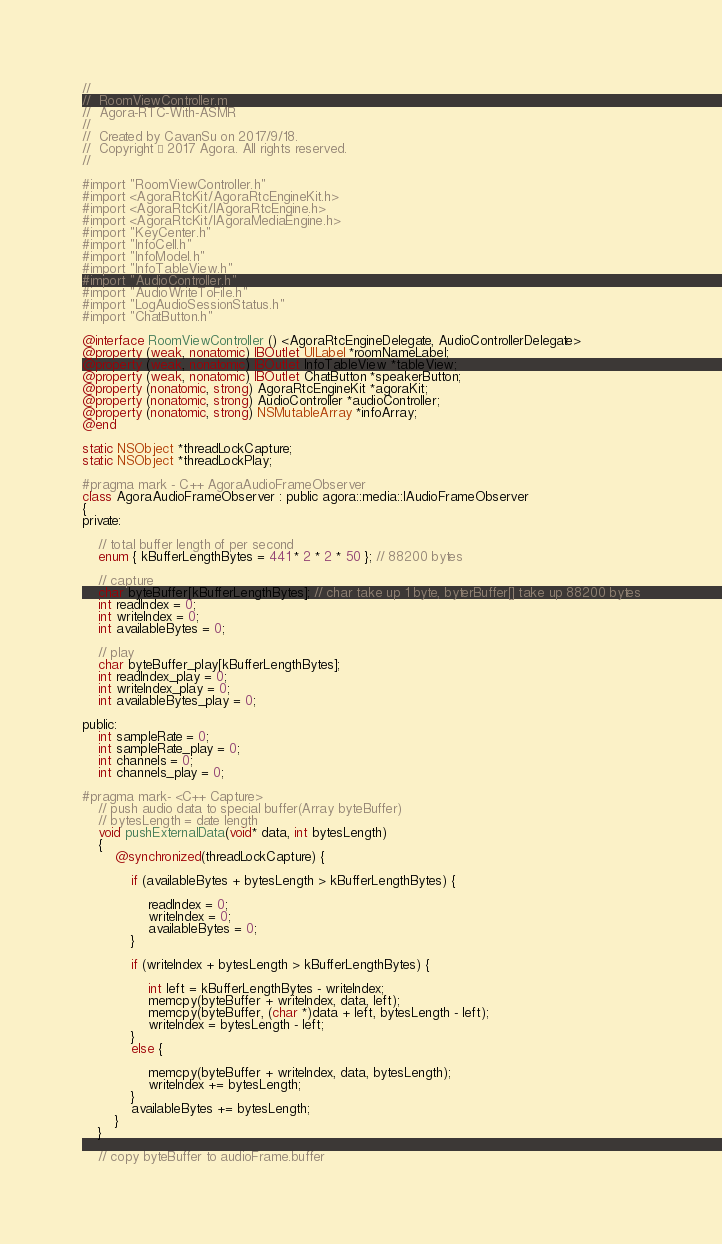<code> <loc_0><loc_0><loc_500><loc_500><_ObjectiveC_>//
//  RoomViewController.m
//  Agora-RTC-With-ASMR
//
//  Created by CavanSu on 2017/9/18.
//  Copyright © 2017 Agora. All rights reserved.
//

#import "RoomViewController.h"
#import <AgoraRtcKit/AgoraRtcEngineKit.h>
#import <AgoraRtcKit/IAgoraRtcEngine.h>
#import <AgoraRtcKit/IAgoraMediaEngine.h>
#import "KeyCenter.h"
#import "InfoCell.h"
#import "InfoModel.h"
#import "InfoTableView.h"
#import "AudioController.h"
#import "AudioWriteToFile.h"
#import "LogAudioSessionStatus.h"
#import "ChatButton.h"

@interface RoomViewController () <AgoraRtcEngineDelegate, AudioControllerDelegate>
@property (weak, nonatomic) IBOutlet UILabel *roomNameLabel;
@property (weak, nonatomic) IBOutlet InfoTableView *tableView;
@property (weak, nonatomic) IBOutlet ChatButton *speakerButton;
@property (nonatomic, strong) AgoraRtcEngineKit *agoraKit;
@property (nonatomic, strong) AudioController *audioController;
@property (nonatomic, strong) NSMutableArray *infoArray;
@end

static NSObject *threadLockCapture;
static NSObject *threadLockPlay;

#pragma mark - C++ AgoraAudioFrameObserver
class AgoraAudioFrameObserver : public agora::media::IAudioFrameObserver
{
private:
    
    // total buffer length of per second
    enum { kBufferLengthBytes = 441 * 2 * 2 * 50 }; // 88200 bytes
    
    // capture
    char byteBuffer[kBufferLengthBytes]; // char take up 1 byte, byterBuffer[] take up 88200 bytes
    int readIndex = 0;
    int writeIndex = 0;
    int availableBytes = 0;
    
    // play
    char byteBuffer_play[kBufferLengthBytes];
    int readIndex_play = 0;
    int writeIndex_play = 0;
    int availableBytes_play = 0;
    
public:
    int sampleRate = 0;
    int sampleRate_play = 0;
    int channels = 0;
    int channels_play = 0;
    
#pragma mark- <C++ Capture>
    // push audio data to special buffer(Array byteBuffer)
    // bytesLength = date length
    void pushExternalData(void* data, int bytesLength)
    {
        @synchronized(threadLockCapture) {
            
            if (availableBytes + bytesLength > kBufferLengthBytes) {
                
                readIndex = 0;
                writeIndex = 0;
                availableBytes = 0;
            }
            
            if (writeIndex + bytesLength > kBufferLengthBytes) {
                
                int left = kBufferLengthBytes - writeIndex;
                memcpy(byteBuffer + writeIndex, data, left);
                memcpy(byteBuffer, (char *)data + left, bytesLength - left);
                writeIndex = bytesLength - left;
            }
            else {
                
                memcpy(byteBuffer + writeIndex, data, bytesLength);
                writeIndex += bytesLength;
            }
            availableBytes += bytesLength;
        }
    }
    
    // copy byteBuffer to audioFrame.buffer</code> 